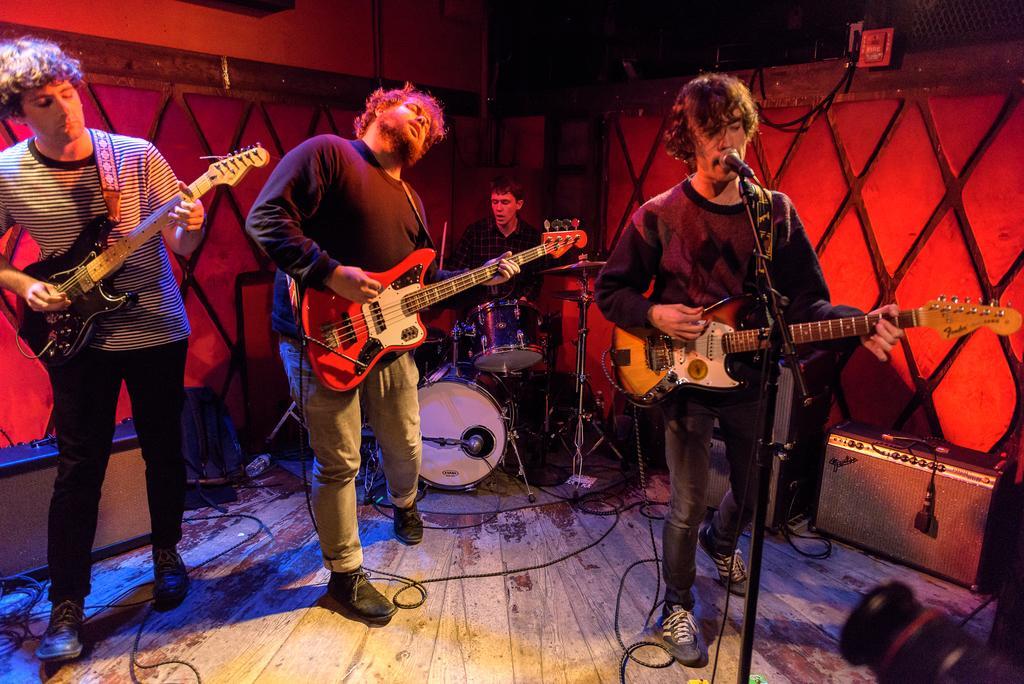How would you summarize this image in a sentence or two? This is the picture of four people who are playing some musical instruments. 